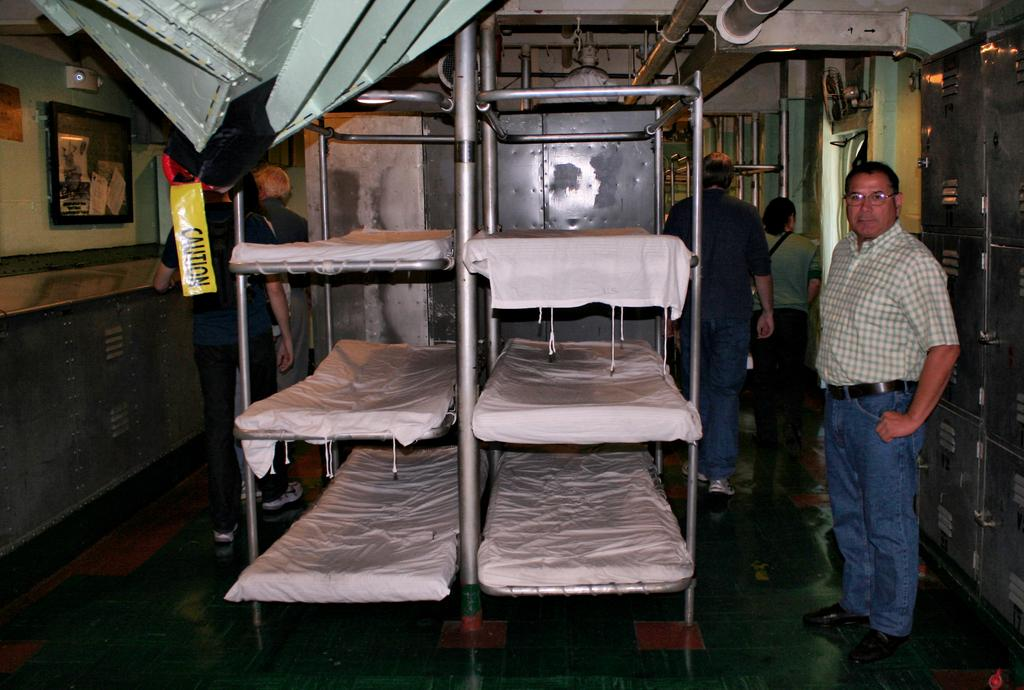<image>
Describe the image concisely. A man stands beside some bunk beds, and some caution tape hands down. 